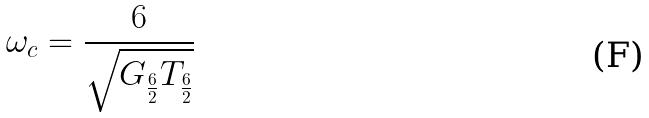Convert formula to latex. <formula><loc_0><loc_0><loc_500><loc_500>\omega _ { c } = \frac { 6 } { \sqrt { G _ { \frac { 6 } { 2 } } T _ { \frac { 6 } { 2 } } } }</formula> 